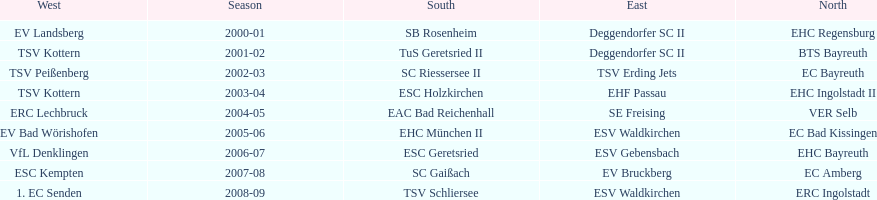How many champions are listend in the north? 9. 